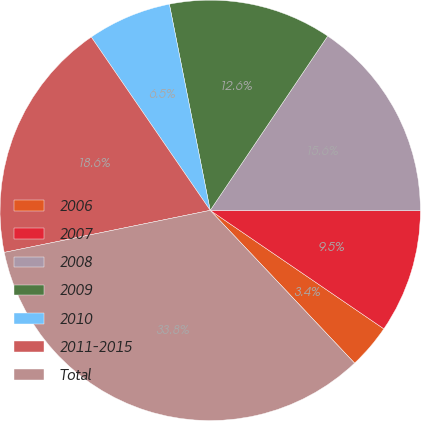Convert chart to OTSL. <chart><loc_0><loc_0><loc_500><loc_500><pie_chart><fcel>2006<fcel>2007<fcel>2008<fcel>2009<fcel>2010<fcel>2011-2015<fcel>Total<nl><fcel>3.42%<fcel>9.5%<fcel>15.59%<fcel>12.55%<fcel>6.46%<fcel>18.63%<fcel>33.84%<nl></chart> 